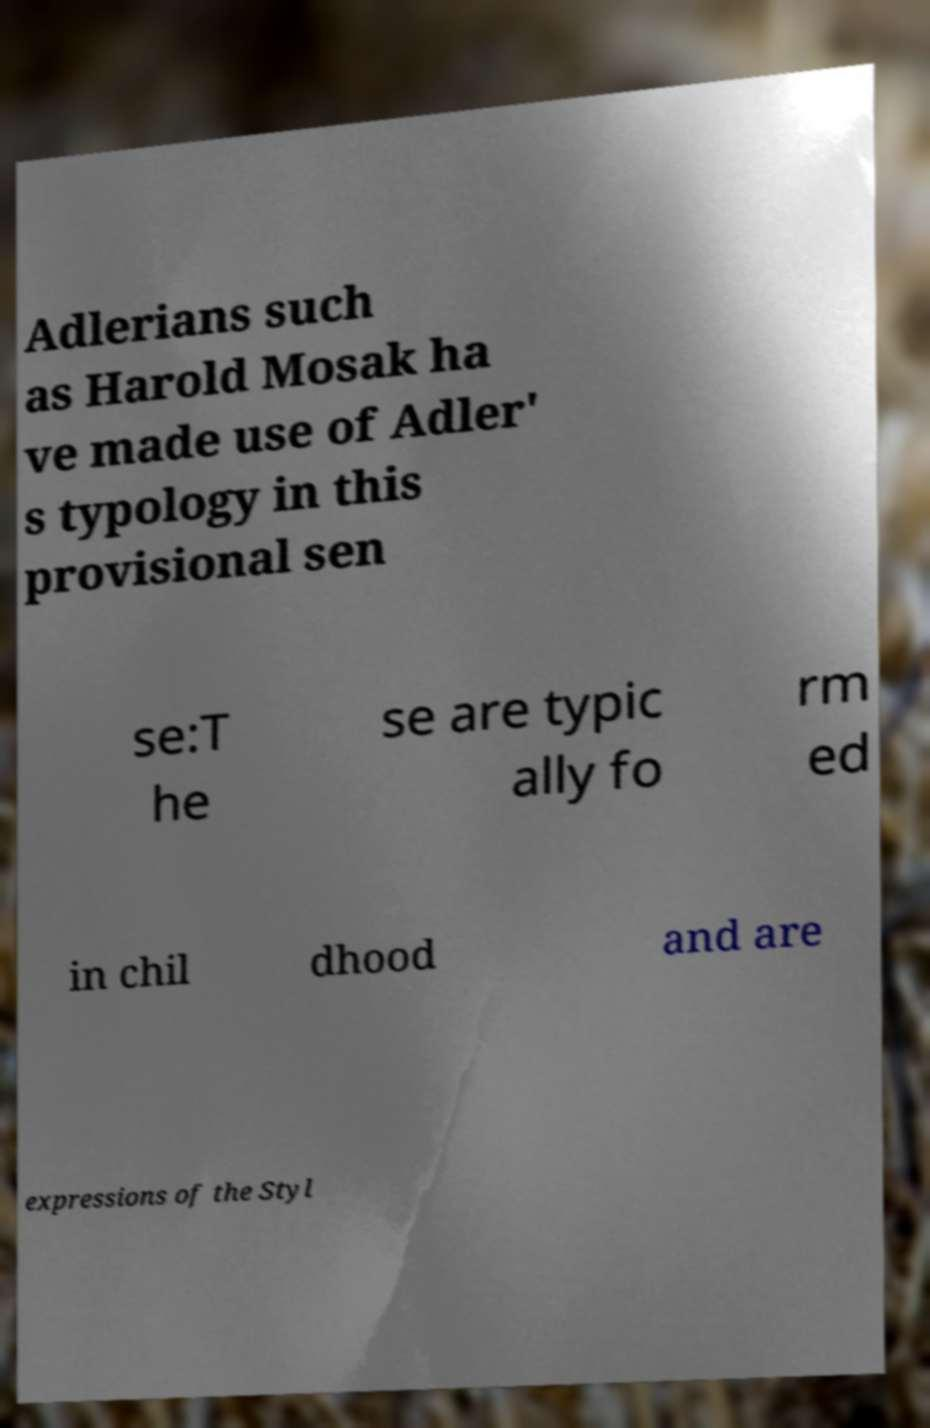Please identify and transcribe the text found in this image. Adlerians such as Harold Mosak ha ve made use of Adler' s typology in this provisional sen se:T he se are typic ally fo rm ed in chil dhood and are expressions of the Styl 